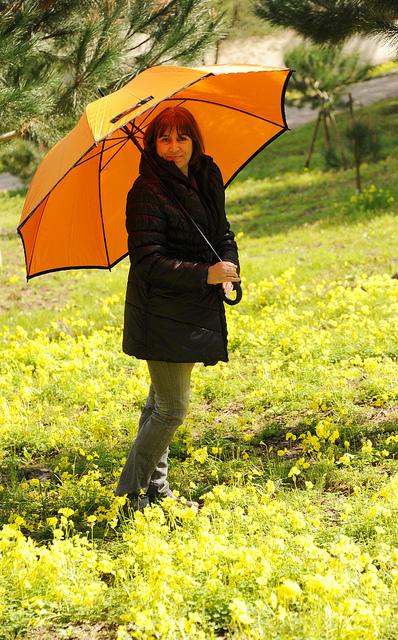Why does the woman have the umbrella open?
Quick response, please. Shade. Are there flowers?
Answer briefly. Yes. Why is the woman wearing a coat?
Short answer required. Cold. 